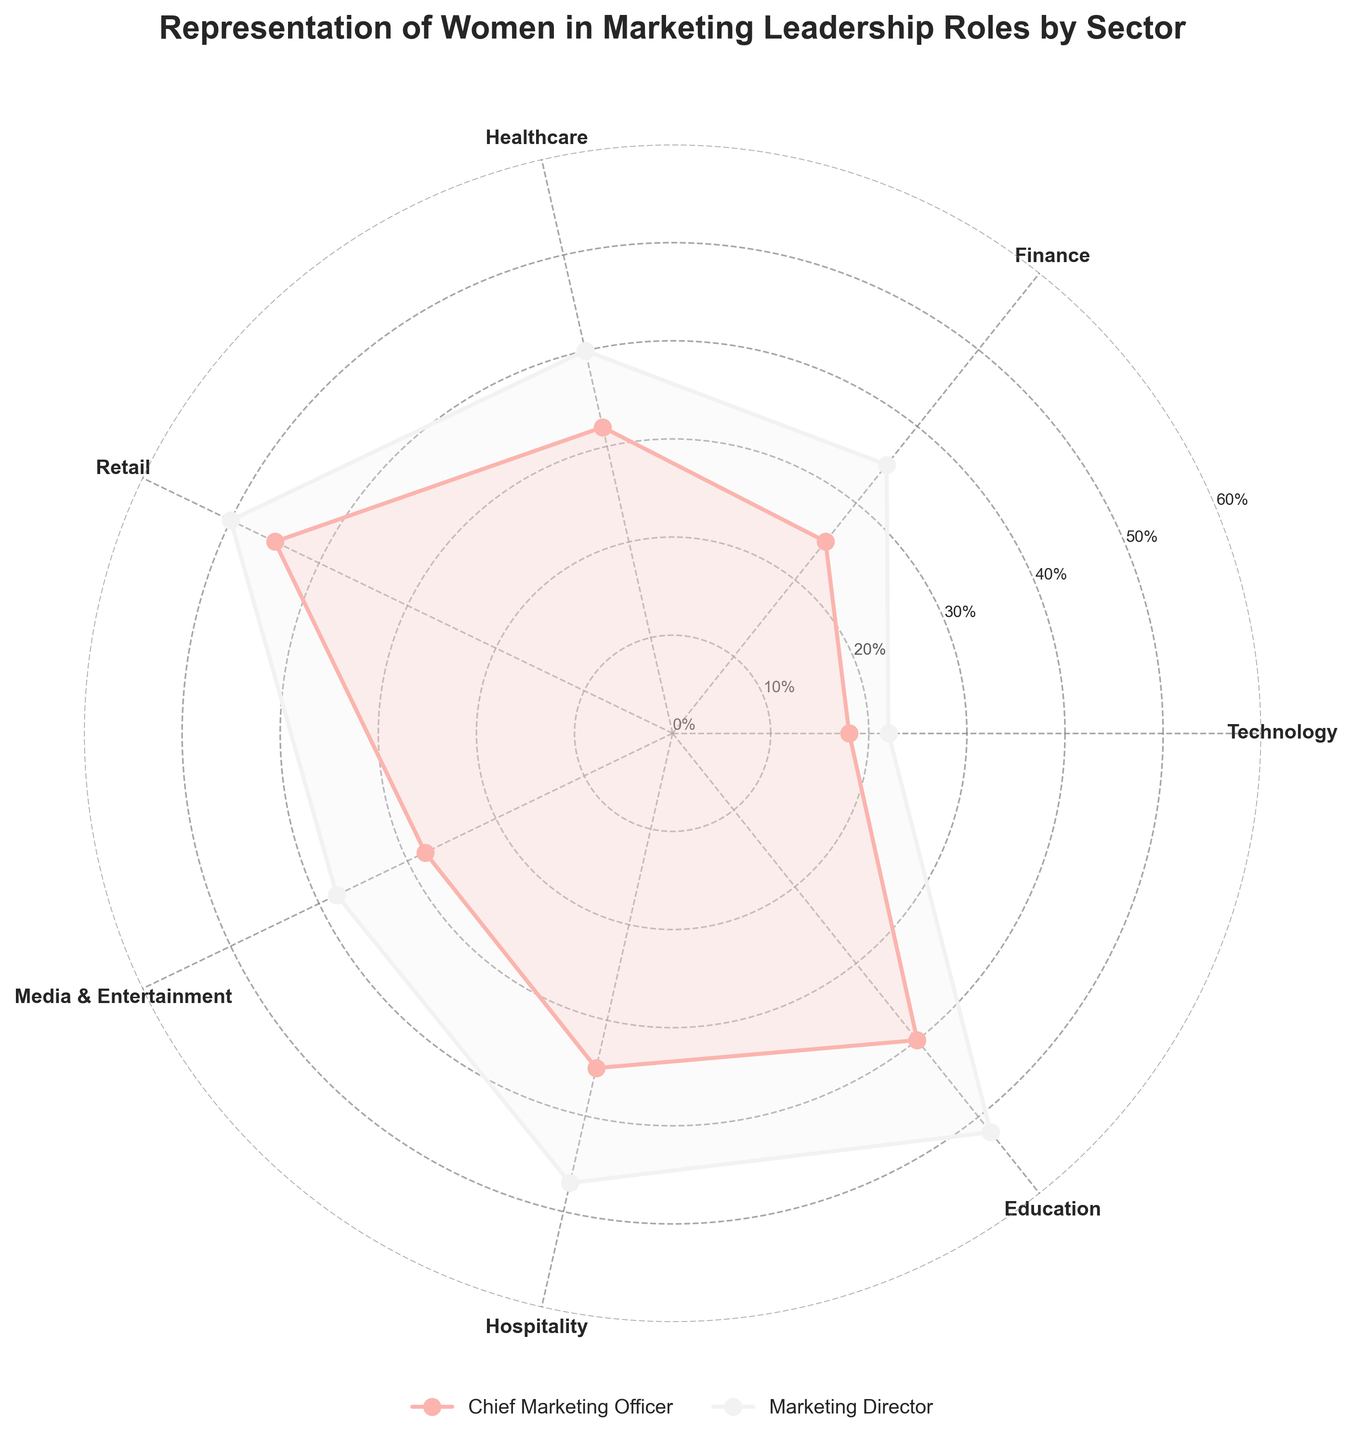What is the sector with the highest percentage of women in the Chief Marketing Officer role? The retail sector has the highest percentage of women in the Chief Marketing Officer role, which is represented by the outermost data point for the role in the polar plot.
Answer: Retail Which role in the education sector has the higher percentage of women? By looking at the angle that represents the education sector, we see two data points. The Marketing Director role is plotted further out, indicating a higher percentage.
Answer: Marketing Director How many sectors have more than 40% representation of women in the Marketing Director role? By inspecting the radius of the data points for Marketing Director roles, the sectors with percentages over 40% are retail, hospitality, and education.
Answer: Three sectors Is there any sector where the Chief Marketing Officer role has a higher percentage of women than the Marketing Director role within the same sector? Comparing the data points for Chief Marketing Officer and Marketing Director roles within each sector, there is no instance where the Chief Marketing Officer has a higher percentage than the Marketing Director.
Answer: No Which sector shows the largest gap in percentage representation between the Chief Marketing Officer and Marketing Director roles? The largest gap can be found by calculating the differences between the two roles across all sectors. The largest difference is seen in education, with Marketing Director at 52% and Chief Marketing Officer at 40%, a gap of 12%.
Answer: Education What is the average percentage of women in the Marketing Director role across all sectors? Sum the percentages of women in the Marketing Director role for all sectors and then divide by the number of sectors: (22 + 35 + 40 + 50 + 38 + 47 + 52) / 7 = 40.57%.
Answer: 40.57% Compare the representation of women in the Chief Marketing Officer roles between the technology and healthcare sectors. The Technology sector shows 18%, while the Healthcare sector has 32%. Healthcare has a higher percentage representation.
Answer: Healthcare Which sector has the smallest combined representation of women in both roles (Chief Marketing Officer and Marketing Director)? Sum the percentages for both roles within each sector and identify the smallest combined sum. Technology has 18% (Chief Marketing Officer) + 22% (Marketing Director) = 40%.
Answer: Technology What is the median percentage of women in the Chief Marketing Officer roles across all sectors? List the percentages for Chief Marketing Officer: (18, 25, 32, 35, 28, 35, 40) and find the middle value, which is 32%.
Answer: 32% Are there any sectors where both roles have exactly the same percentage of female representation? By observing the data points for both roles within each sector, there is no sector where the percentages match exactly.
Answer: No 